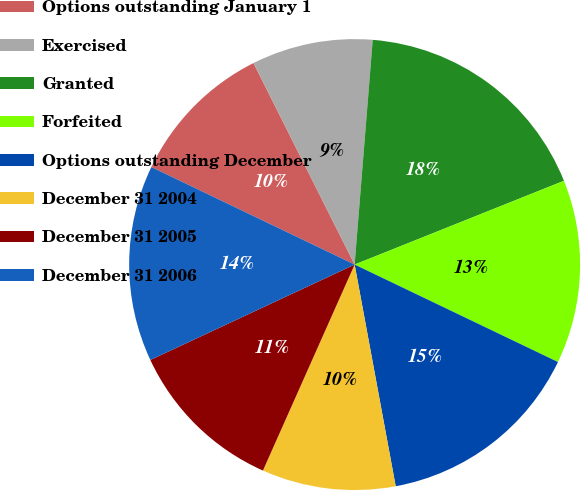<chart> <loc_0><loc_0><loc_500><loc_500><pie_chart><fcel>Options outstanding January 1<fcel>Exercised<fcel>Granted<fcel>Forfeited<fcel>Options outstanding December<fcel>December 31 2004<fcel>December 31 2005<fcel>December 31 2006<nl><fcel>10.48%<fcel>8.68%<fcel>17.66%<fcel>13.17%<fcel>14.97%<fcel>9.58%<fcel>11.38%<fcel>14.07%<nl></chart> 